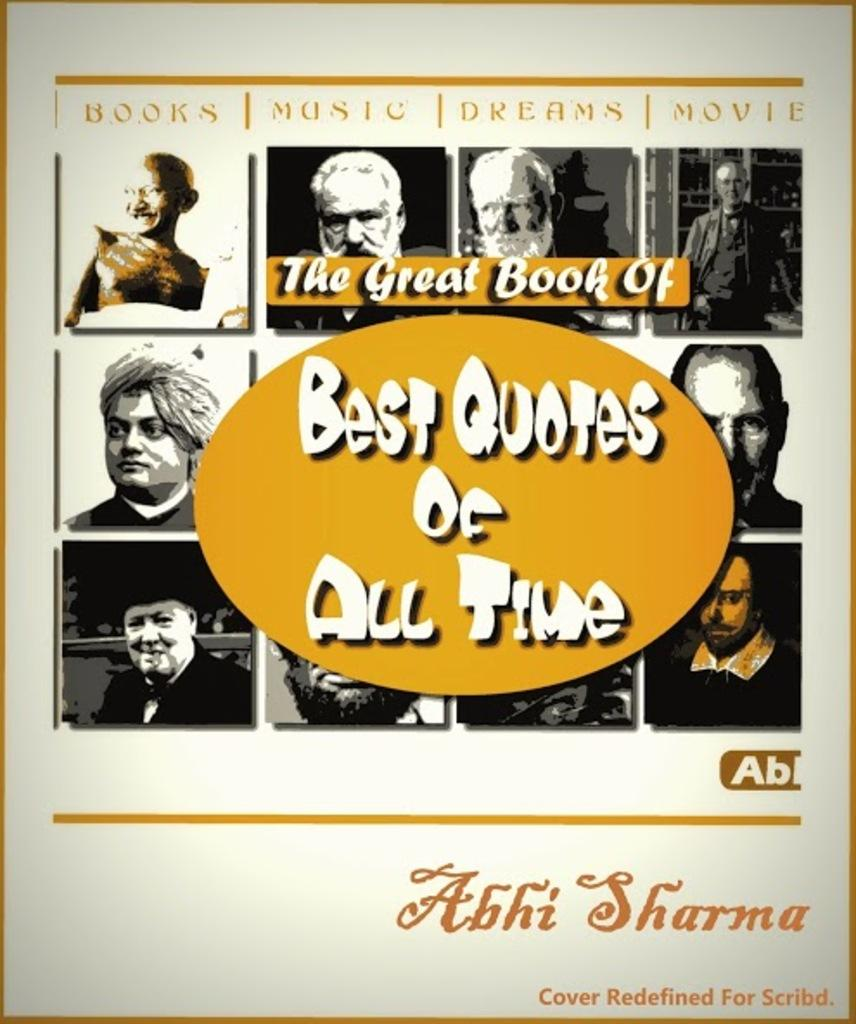What is present in the image that contains both images and text? There is a poster in the image that contains images and text. What type of island is depicted in the poster? There is no island depicted in the poster; it contains images and text, but no island. What kind of discussion is taking place in the image? There is no discussion taking place in the image; it only features a poster with images and text. 